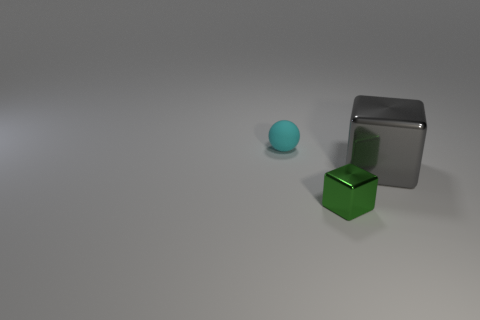Add 1 green rubber objects. How many objects exist? 4 Subtract 2 blocks. How many blocks are left? 0 Subtract all spheres. How many objects are left? 2 Subtract all red blocks. Subtract all brown cylinders. How many blocks are left? 2 Subtract all large purple metal spheres. Subtract all green objects. How many objects are left? 2 Add 3 small rubber things. How many small rubber things are left? 4 Add 1 spheres. How many spheres exist? 2 Subtract 0 brown spheres. How many objects are left? 3 